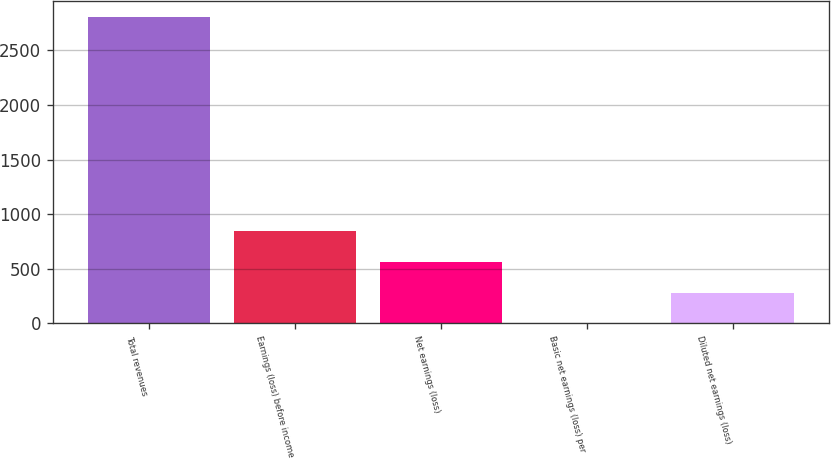Convert chart. <chart><loc_0><loc_0><loc_500><loc_500><bar_chart><fcel>Total revenues<fcel>Earnings (loss) before income<fcel>Net earnings (loss)<fcel>Basic net earnings (loss) per<fcel>Diluted net earnings (loss)<nl><fcel>2808<fcel>842.69<fcel>561.93<fcel>0.41<fcel>281.17<nl></chart> 